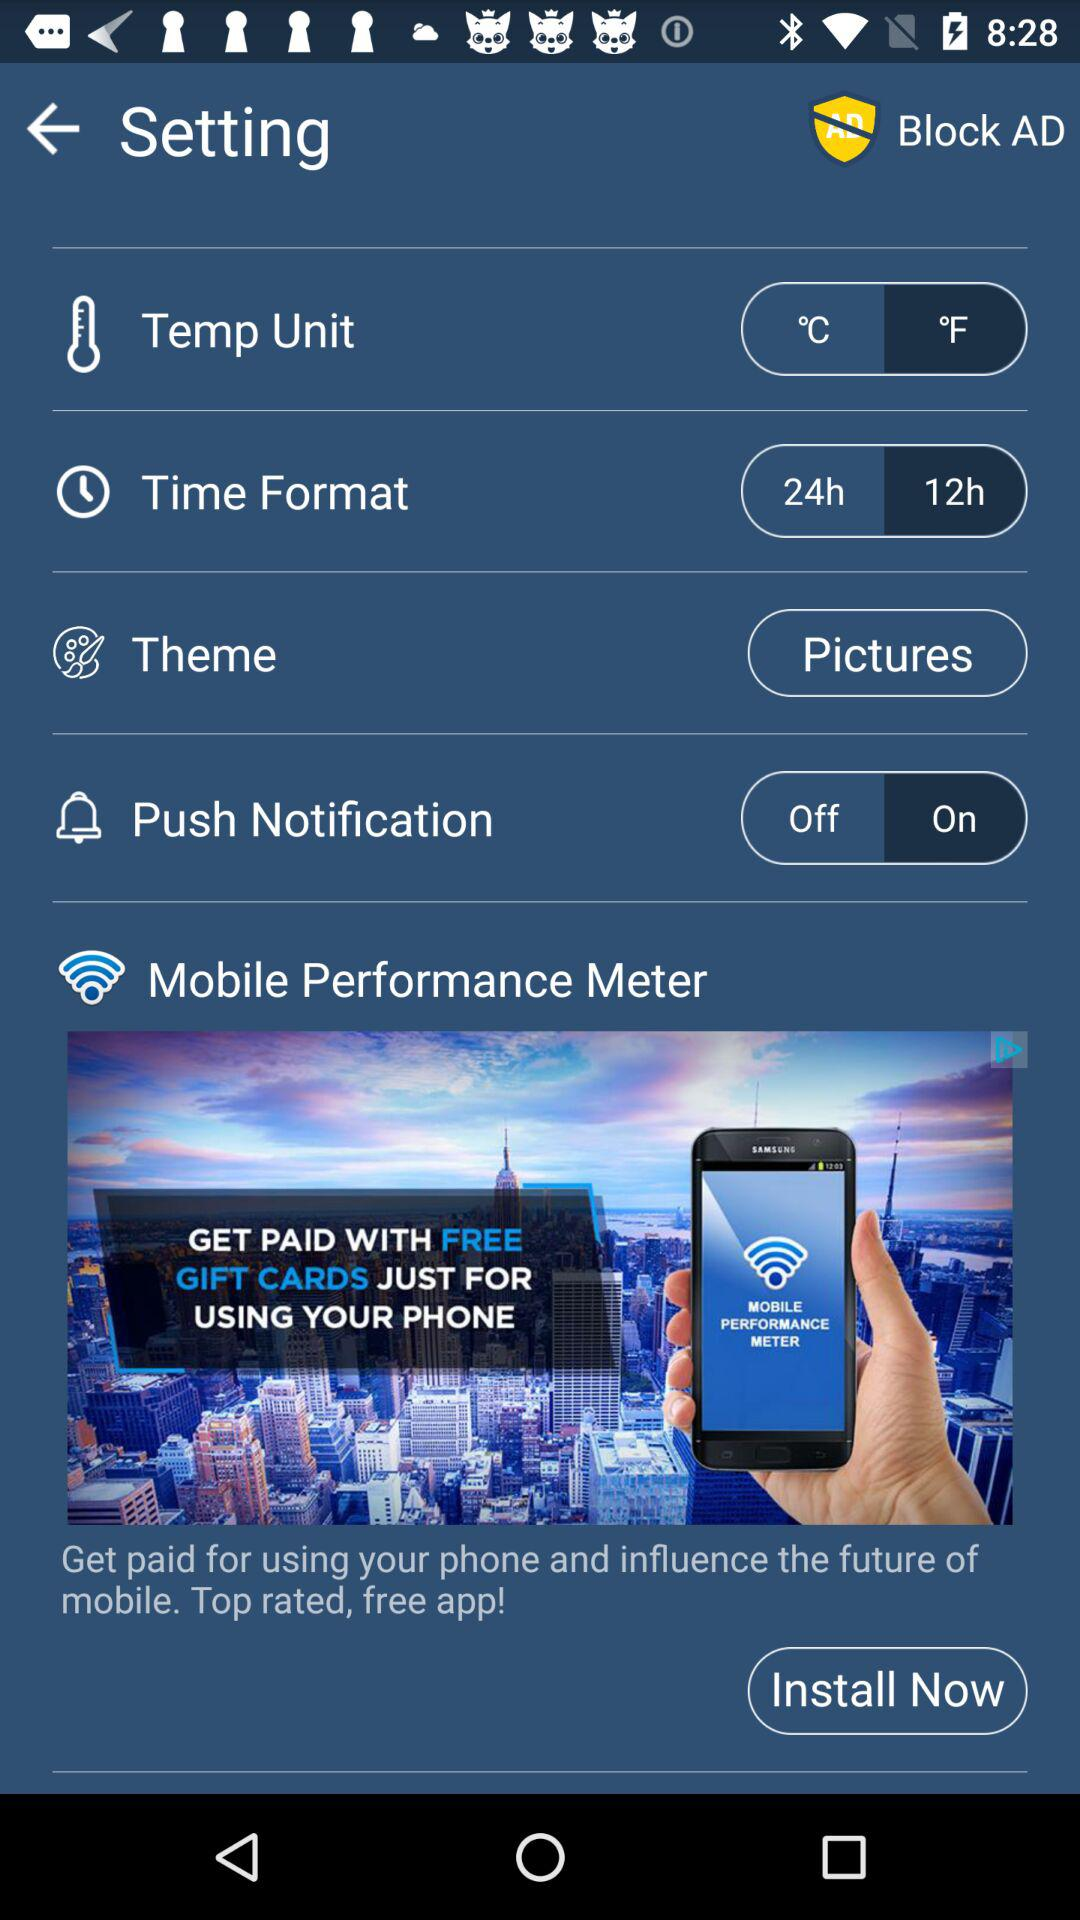Which is the selected temperature unit? The selected temperature unit is °F. 